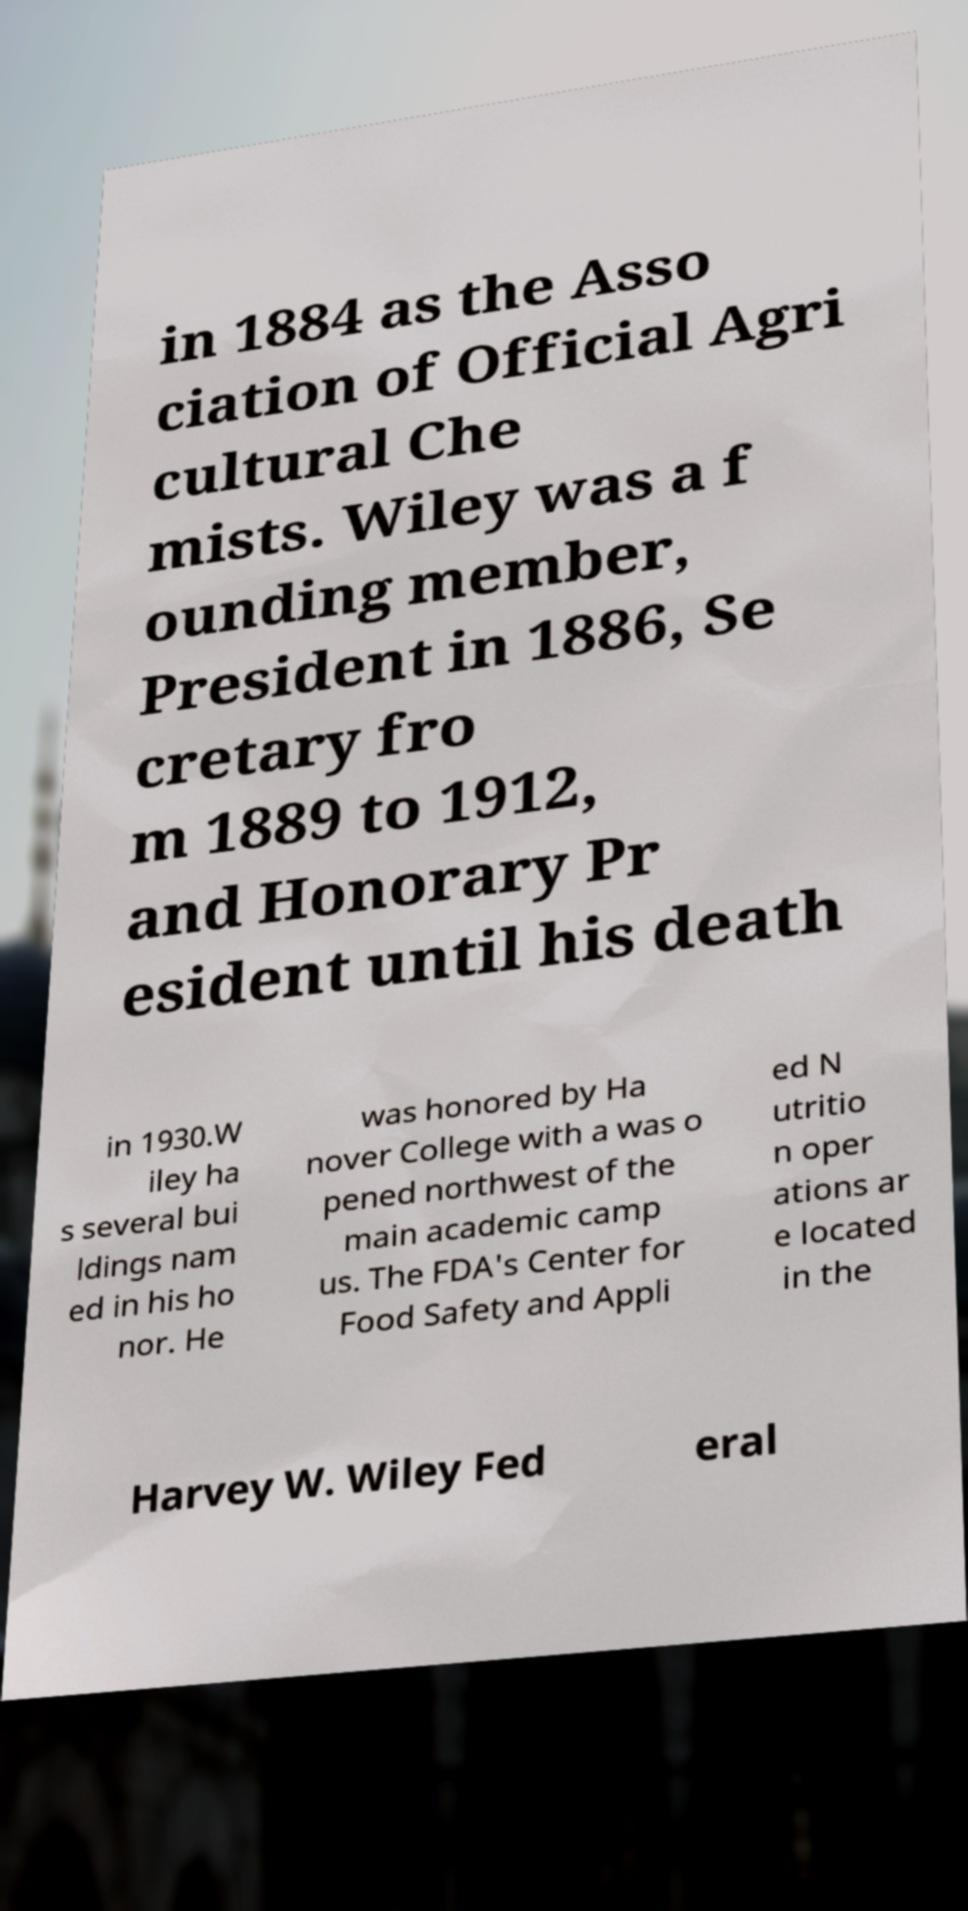Could you extract and type out the text from this image? in 1884 as the Asso ciation of Official Agri cultural Che mists. Wiley was a f ounding member, President in 1886, Se cretary fro m 1889 to 1912, and Honorary Pr esident until his death in 1930.W iley ha s several bui ldings nam ed in his ho nor. He was honored by Ha nover College with a was o pened northwest of the main academic camp us. The FDA's Center for Food Safety and Appli ed N utritio n oper ations ar e located in the Harvey W. Wiley Fed eral 